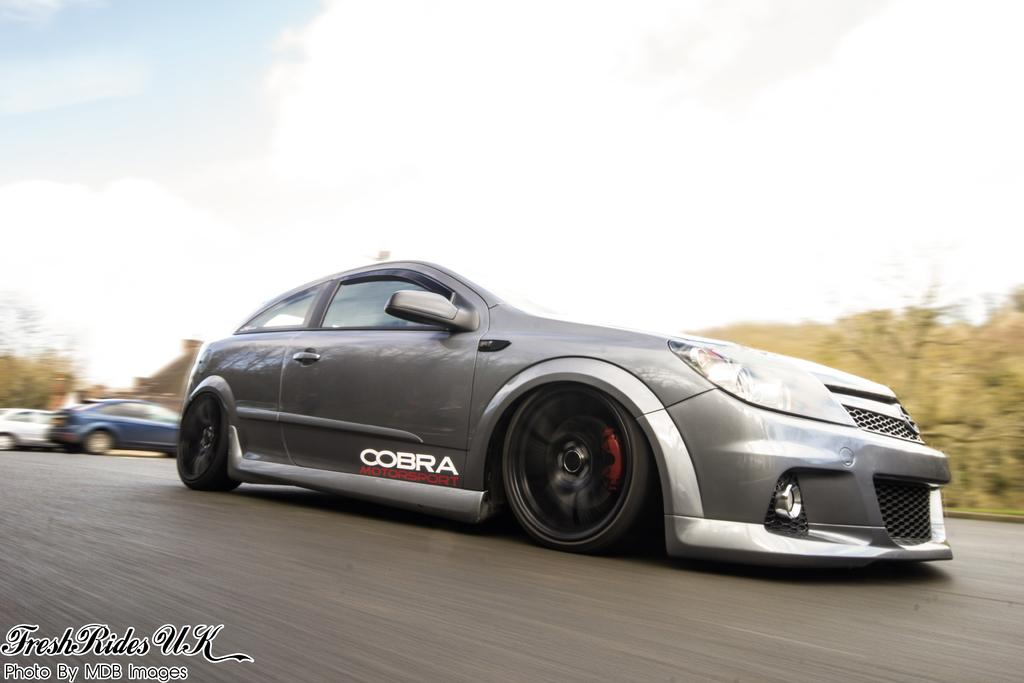What is the main subject of the image? The main subject of the image is a car. Where is the car located in the image? The car is on a road in the image. Are there any other cars visible in the image? Yes, there are two cars behind the first car. What can be seen in the background of the image? Trees and the sky are visible in the background of the image. What is the condition of the sky in the image? The sky is visible with clouds present in the image. Can you tell me where the umbrella is located in the image? There is no umbrella present in the image. Is the car stuck in quicksand in the image? There is no quicksand present in the image; the car is on a road. 